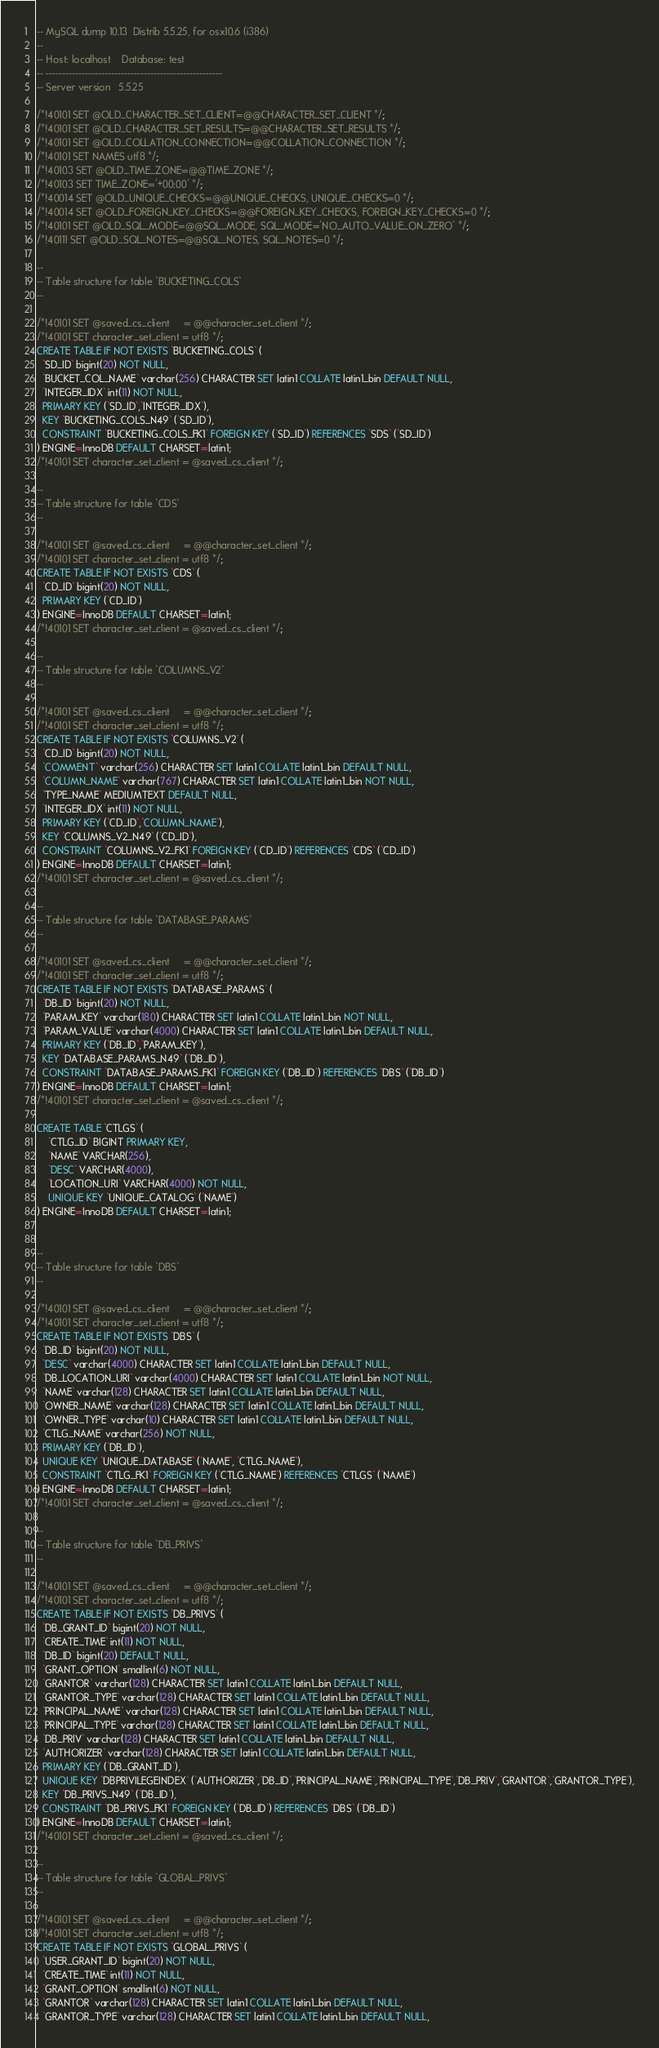Convert code to text. <code><loc_0><loc_0><loc_500><loc_500><_SQL_>-- MySQL dump 10.13  Distrib 5.5.25, for osx10.6 (i386)
--
-- Host: localhost    Database: test
-- ------------------------------------------------------
-- Server version	5.5.25

/*!40101 SET @OLD_CHARACTER_SET_CLIENT=@@CHARACTER_SET_CLIENT */;
/*!40101 SET @OLD_CHARACTER_SET_RESULTS=@@CHARACTER_SET_RESULTS */;
/*!40101 SET @OLD_COLLATION_CONNECTION=@@COLLATION_CONNECTION */;
/*!40101 SET NAMES utf8 */;
/*!40103 SET @OLD_TIME_ZONE=@@TIME_ZONE */;
/*!40103 SET TIME_ZONE='+00:00' */;
/*!40014 SET @OLD_UNIQUE_CHECKS=@@UNIQUE_CHECKS, UNIQUE_CHECKS=0 */;
/*!40014 SET @OLD_FOREIGN_KEY_CHECKS=@@FOREIGN_KEY_CHECKS, FOREIGN_KEY_CHECKS=0 */;
/*!40101 SET @OLD_SQL_MODE=@@SQL_MODE, SQL_MODE='NO_AUTO_VALUE_ON_ZERO' */;
/*!40111 SET @OLD_SQL_NOTES=@@SQL_NOTES, SQL_NOTES=0 */;

--
-- Table structure for table `BUCKETING_COLS`
--

/*!40101 SET @saved_cs_client     = @@character_set_client */;
/*!40101 SET character_set_client = utf8 */;
CREATE TABLE IF NOT EXISTS `BUCKETING_COLS` (
  `SD_ID` bigint(20) NOT NULL,
  `BUCKET_COL_NAME` varchar(256) CHARACTER SET latin1 COLLATE latin1_bin DEFAULT NULL,
  `INTEGER_IDX` int(11) NOT NULL,
  PRIMARY KEY (`SD_ID`,`INTEGER_IDX`),
  KEY `BUCKETING_COLS_N49` (`SD_ID`),
  CONSTRAINT `BUCKETING_COLS_FK1` FOREIGN KEY (`SD_ID`) REFERENCES `SDS` (`SD_ID`)
) ENGINE=InnoDB DEFAULT CHARSET=latin1;
/*!40101 SET character_set_client = @saved_cs_client */;

--
-- Table structure for table `CDS`
--

/*!40101 SET @saved_cs_client     = @@character_set_client */;
/*!40101 SET character_set_client = utf8 */;
CREATE TABLE IF NOT EXISTS `CDS` (
  `CD_ID` bigint(20) NOT NULL,
  PRIMARY KEY (`CD_ID`)
) ENGINE=InnoDB DEFAULT CHARSET=latin1;
/*!40101 SET character_set_client = @saved_cs_client */;

--
-- Table structure for table `COLUMNS_V2`
--

/*!40101 SET @saved_cs_client     = @@character_set_client */;
/*!40101 SET character_set_client = utf8 */;
CREATE TABLE IF NOT EXISTS `COLUMNS_V2` (
  `CD_ID` bigint(20) NOT NULL,
  `COMMENT` varchar(256) CHARACTER SET latin1 COLLATE latin1_bin DEFAULT NULL,
  `COLUMN_NAME` varchar(767) CHARACTER SET latin1 COLLATE latin1_bin NOT NULL,
  `TYPE_NAME` MEDIUMTEXT DEFAULT NULL,
  `INTEGER_IDX` int(11) NOT NULL,
  PRIMARY KEY (`CD_ID`,`COLUMN_NAME`),
  KEY `COLUMNS_V2_N49` (`CD_ID`),
  CONSTRAINT `COLUMNS_V2_FK1` FOREIGN KEY (`CD_ID`) REFERENCES `CDS` (`CD_ID`)
) ENGINE=InnoDB DEFAULT CHARSET=latin1;
/*!40101 SET character_set_client = @saved_cs_client */;

--
-- Table structure for table `DATABASE_PARAMS`
--

/*!40101 SET @saved_cs_client     = @@character_set_client */;
/*!40101 SET character_set_client = utf8 */;
CREATE TABLE IF NOT EXISTS `DATABASE_PARAMS` (
  `DB_ID` bigint(20) NOT NULL,
  `PARAM_KEY` varchar(180) CHARACTER SET latin1 COLLATE latin1_bin NOT NULL,
  `PARAM_VALUE` varchar(4000) CHARACTER SET latin1 COLLATE latin1_bin DEFAULT NULL,
  PRIMARY KEY (`DB_ID`,`PARAM_KEY`),
  KEY `DATABASE_PARAMS_N49` (`DB_ID`),
  CONSTRAINT `DATABASE_PARAMS_FK1` FOREIGN KEY (`DB_ID`) REFERENCES `DBS` (`DB_ID`)
) ENGINE=InnoDB DEFAULT CHARSET=latin1;
/*!40101 SET character_set_client = @saved_cs_client */;

CREATE TABLE `CTLGS` (
    `CTLG_ID` BIGINT PRIMARY KEY,
    `NAME` VARCHAR(256),
    `DESC` VARCHAR(4000),
    `LOCATION_URI` VARCHAR(4000) NOT NULL,
    UNIQUE KEY `UNIQUE_CATALOG` (`NAME`)
) ENGINE=InnoDB DEFAULT CHARSET=latin1;


--
-- Table structure for table `DBS`
--

/*!40101 SET @saved_cs_client     = @@character_set_client */;
/*!40101 SET character_set_client = utf8 */;
CREATE TABLE IF NOT EXISTS `DBS` (
  `DB_ID` bigint(20) NOT NULL,
  `DESC` varchar(4000) CHARACTER SET latin1 COLLATE latin1_bin DEFAULT NULL,
  `DB_LOCATION_URI` varchar(4000) CHARACTER SET latin1 COLLATE latin1_bin NOT NULL,
  `NAME` varchar(128) CHARACTER SET latin1 COLLATE latin1_bin DEFAULT NULL,
  `OWNER_NAME` varchar(128) CHARACTER SET latin1 COLLATE latin1_bin DEFAULT NULL,
  `OWNER_TYPE` varchar(10) CHARACTER SET latin1 COLLATE latin1_bin DEFAULT NULL,
  `CTLG_NAME` varchar(256) NOT NULL,
  PRIMARY KEY (`DB_ID`),
  UNIQUE KEY `UNIQUE_DATABASE` (`NAME`, `CTLG_NAME`),
  CONSTRAINT `CTLG_FK1` FOREIGN KEY (`CTLG_NAME`) REFERENCES `CTLGS` (`NAME`)
) ENGINE=InnoDB DEFAULT CHARSET=latin1;
/*!40101 SET character_set_client = @saved_cs_client */;

--
-- Table structure for table `DB_PRIVS`
--

/*!40101 SET @saved_cs_client     = @@character_set_client */;
/*!40101 SET character_set_client = utf8 */;
CREATE TABLE IF NOT EXISTS `DB_PRIVS` (
  `DB_GRANT_ID` bigint(20) NOT NULL,
  `CREATE_TIME` int(11) NOT NULL,
  `DB_ID` bigint(20) DEFAULT NULL,
  `GRANT_OPTION` smallint(6) NOT NULL,
  `GRANTOR` varchar(128) CHARACTER SET latin1 COLLATE latin1_bin DEFAULT NULL,
  `GRANTOR_TYPE` varchar(128) CHARACTER SET latin1 COLLATE latin1_bin DEFAULT NULL,
  `PRINCIPAL_NAME` varchar(128) CHARACTER SET latin1 COLLATE latin1_bin DEFAULT NULL,
  `PRINCIPAL_TYPE` varchar(128) CHARACTER SET latin1 COLLATE latin1_bin DEFAULT NULL,
  `DB_PRIV` varchar(128) CHARACTER SET latin1 COLLATE latin1_bin DEFAULT NULL,
  `AUTHORIZER` varchar(128) CHARACTER SET latin1 COLLATE latin1_bin DEFAULT NULL,
  PRIMARY KEY (`DB_GRANT_ID`),
  UNIQUE KEY `DBPRIVILEGEINDEX` (`AUTHORIZER`,`DB_ID`,`PRINCIPAL_NAME`,`PRINCIPAL_TYPE`,`DB_PRIV`,`GRANTOR`,`GRANTOR_TYPE`),
  KEY `DB_PRIVS_N49` (`DB_ID`),
  CONSTRAINT `DB_PRIVS_FK1` FOREIGN KEY (`DB_ID`) REFERENCES `DBS` (`DB_ID`)
) ENGINE=InnoDB DEFAULT CHARSET=latin1;
/*!40101 SET character_set_client = @saved_cs_client */;

--
-- Table structure for table `GLOBAL_PRIVS`
--

/*!40101 SET @saved_cs_client     = @@character_set_client */;
/*!40101 SET character_set_client = utf8 */;
CREATE TABLE IF NOT EXISTS `GLOBAL_PRIVS` (
  `USER_GRANT_ID` bigint(20) NOT NULL,
  `CREATE_TIME` int(11) NOT NULL,
  `GRANT_OPTION` smallint(6) NOT NULL,
  `GRANTOR` varchar(128) CHARACTER SET latin1 COLLATE latin1_bin DEFAULT NULL,
  `GRANTOR_TYPE` varchar(128) CHARACTER SET latin1 COLLATE latin1_bin DEFAULT NULL,</code> 